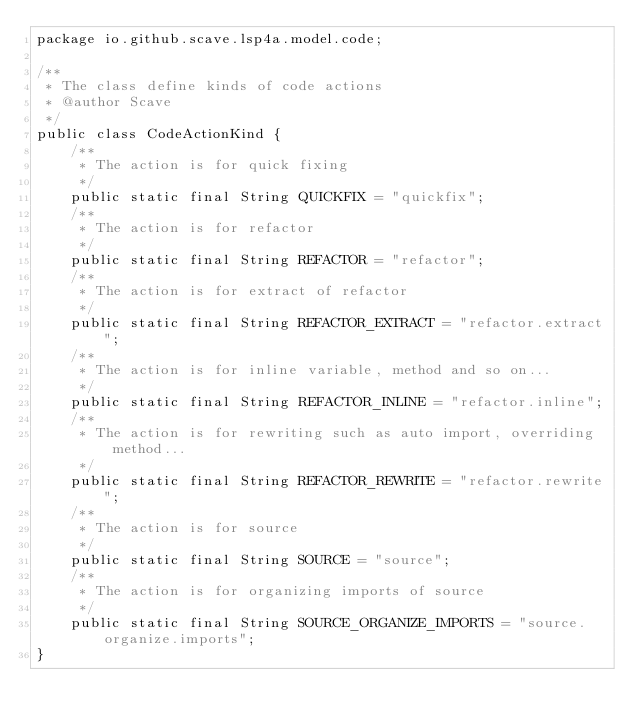<code> <loc_0><loc_0><loc_500><loc_500><_Java_>package io.github.scave.lsp4a.model.code;

/**
 * The class define kinds of code actions
 * @author Scave
 */
public class CodeActionKind {
    /**
     * The action is for quick fixing
     */
    public static final String QUICKFIX = "quickfix";
    /**
     * The action is for refactor
     */
    public static final String REFACTOR = "refactor";
    /**
     * The action is for extract of refactor
     */
    public static final String REFACTOR_EXTRACT = "refactor.extract";
    /**
     * The action is for inline variable, method and so on...
     */
    public static final String REFACTOR_INLINE = "refactor.inline";
    /**
     * The action is for rewriting such as auto import, overriding method...
     */
    public static final String REFACTOR_REWRITE = "refactor.rewrite";
    /**
     * The action is for source
     */
    public static final String SOURCE = "source";
    /**
     * The action is for organizing imports of source
     */
    public static final String SOURCE_ORGANIZE_IMPORTS = "source.organize.imports";
}
</code> 